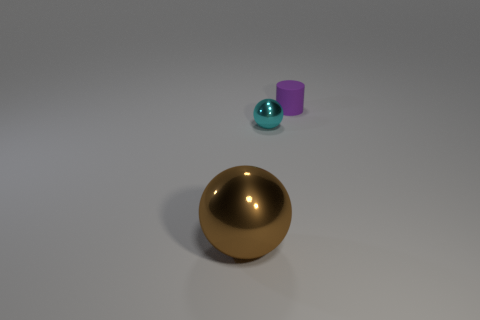Add 3 red shiny cubes. How many objects exist? 6 Subtract all spheres. How many objects are left? 1 Add 2 tiny purple rubber things. How many tiny purple rubber things are left? 3 Add 3 large gray rubber spheres. How many large gray rubber spheres exist? 3 Subtract 0 blue spheres. How many objects are left? 3 Subtract all tiny rubber cylinders. Subtract all large metal balls. How many objects are left? 1 